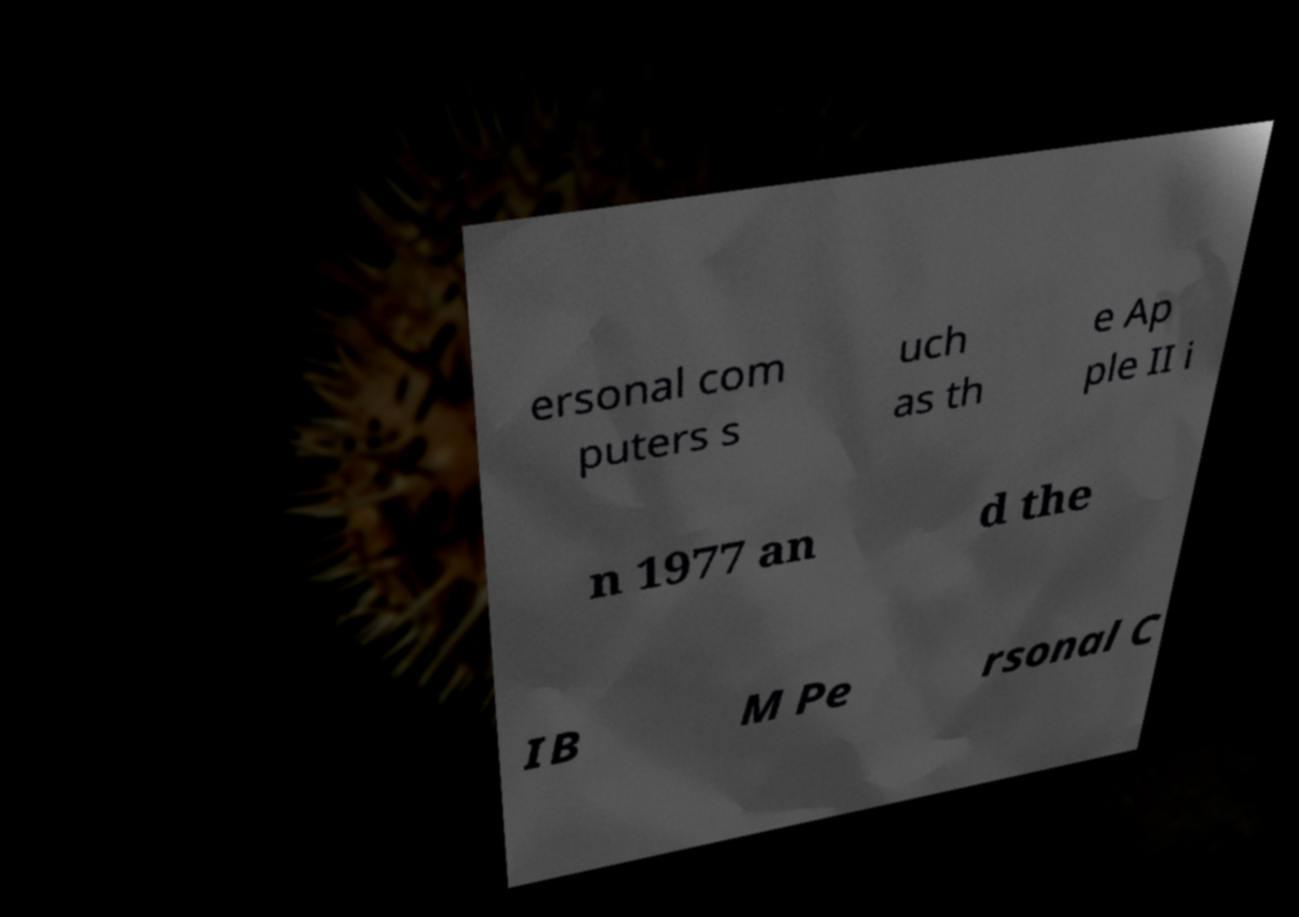Please identify and transcribe the text found in this image. ersonal com puters s uch as th e Ap ple II i n 1977 an d the IB M Pe rsonal C 